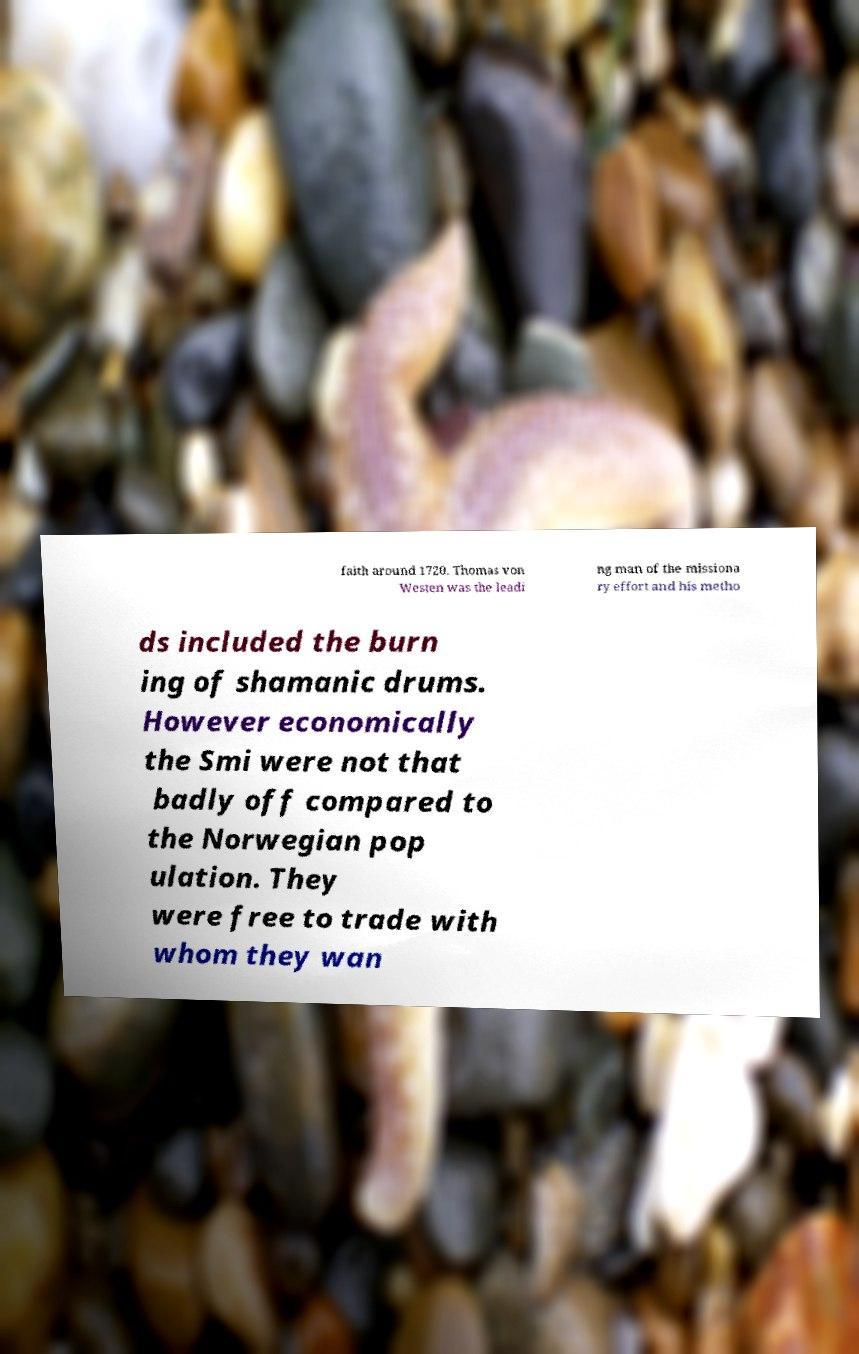Can you accurately transcribe the text from the provided image for me? faith around 1720. Thomas von Westen was the leadi ng man of the missiona ry effort and his metho ds included the burn ing of shamanic drums. However economically the Smi were not that badly off compared to the Norwegian pop ulation. They were free to trade with whom they wan 